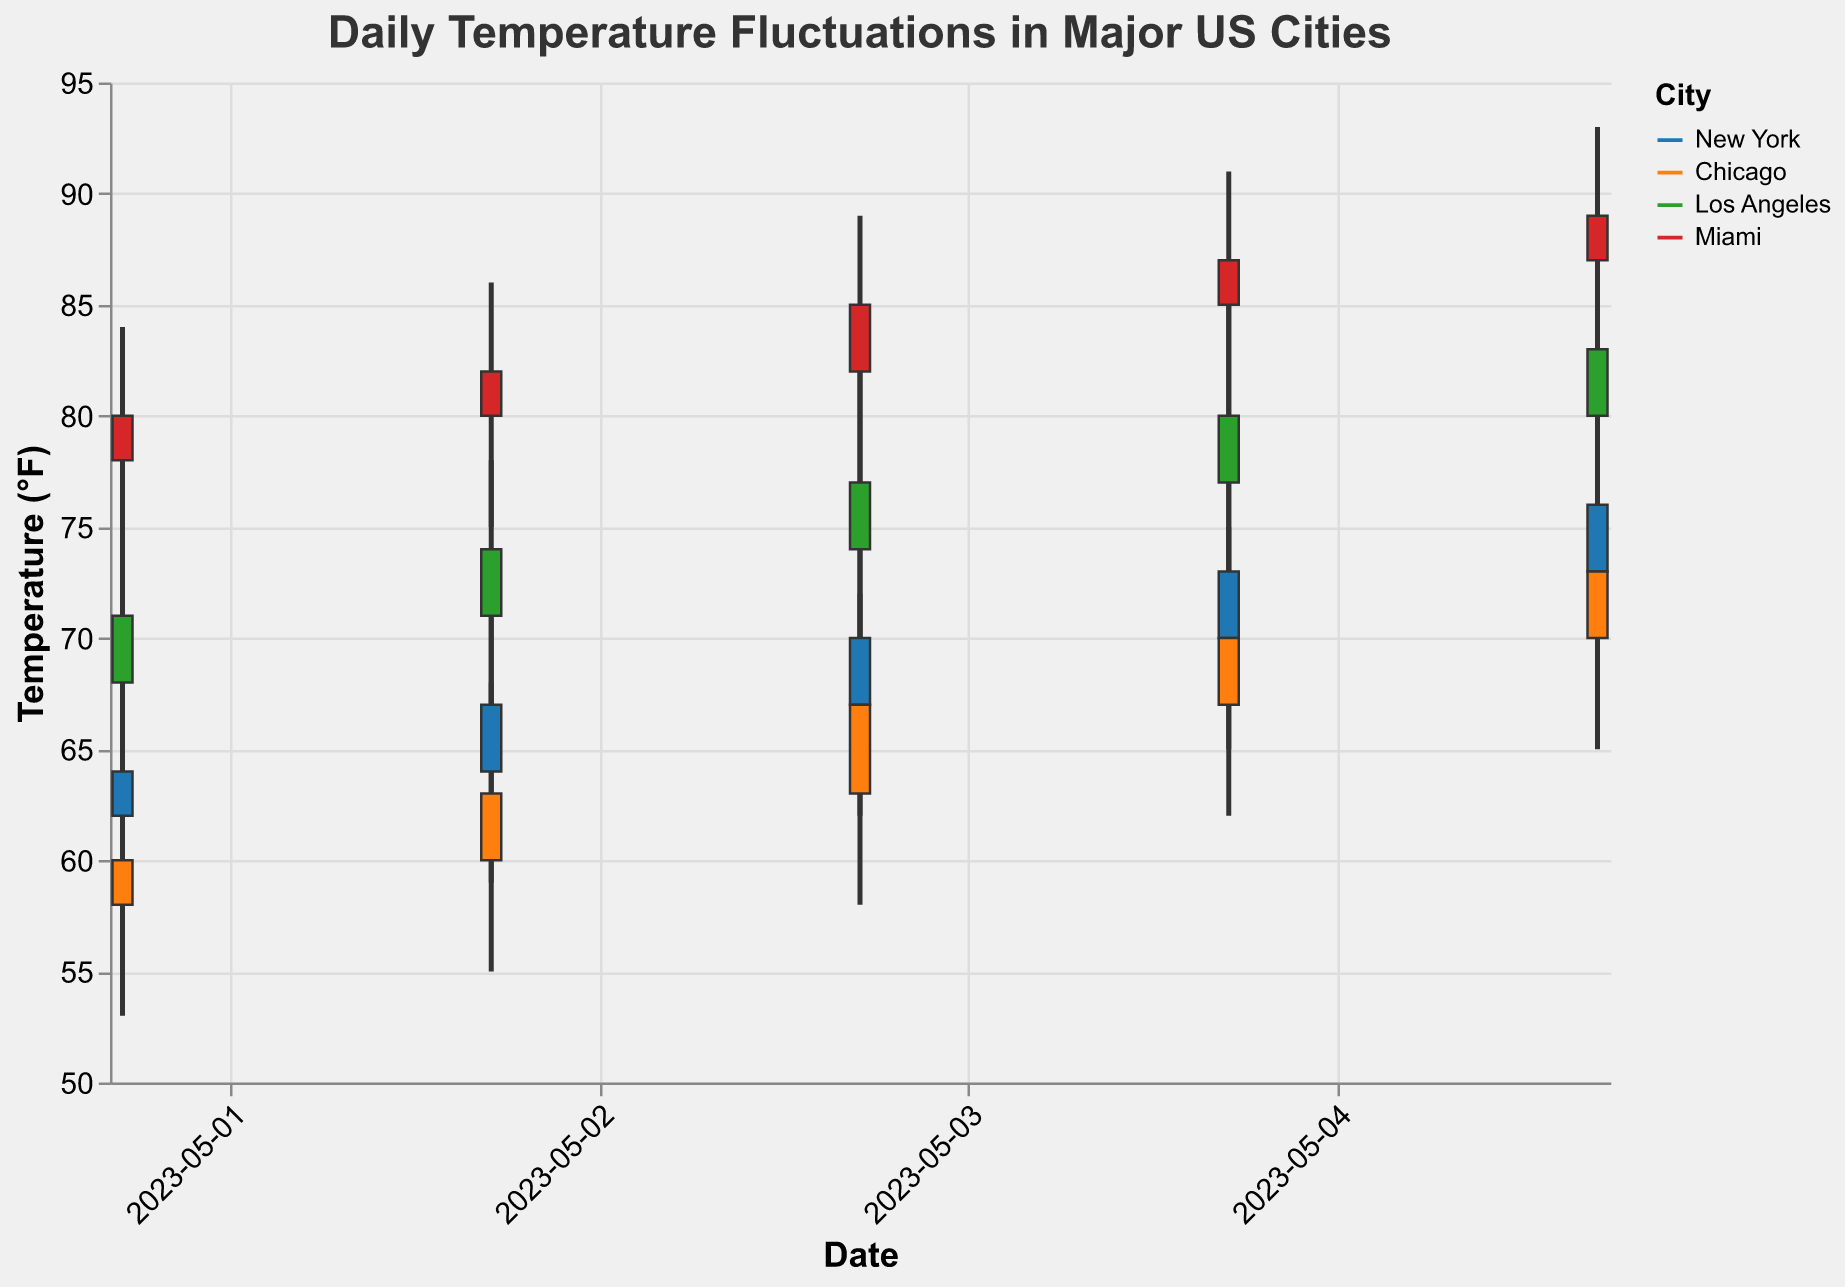What is the highest temperature recorded in New York during the 5 days shown? The highest temperature can be found by examining the "High" values for New York. The values are 68, 71, 75, 78, and 80. Among these, the highest is 80.
Answer: 80°F What city experienced the highest overall temperature? To determine which city experienced the highest temperature, we look at the "High" values for each city across all dates. The maximum values are: New York (80), Chicago (78), Los Angeles (88), and Miami (93). The highest among these is 93 in Miami.
Answer: Miami Which city had the smallest temperature range on May 03, 2023? To determine the smallest temperature range, we check the difference between the "High" and "Low" for each city on May 03. Calculations: New York (75 - 62 = 13), Chicago (72 - 58 = 14), Los Angeles (82 - 69 = 13), Miami (89 - 77 = 12). So, Miami has the smallest range.
Answer: Miami How did the closing temperature of New York change from May 01 to May 05? To observe the change, compare the "Close" values for New York on May 01 and May 05. On May 01, the closing temperature was 64°F, and on May 05, it was 76°F. The change is 76 - 64 = 12°F.
Answer: 12°F increase Which city had the most consistent temperatures over the 5 days? Consistency can be assessed by examining the day-to-day variation in closing temperatures. Checking the "Close" values: 
- New York: 64, 67, 70, 73, 76 (variations are 3, 3, 3, 3)
- Chicago: 60, 63, 67, 70, 73 (variations are 3, 4, 3, 3)
- Los Angeles: 71, 74, 77, 80, 83 (variations are 3, 3, 3, 3)
- Miami: 80, 82, 85, 87, 89 (variations are 2, 3, 2, 2)
Miami has the smallest daily variations overall.
Answer: Miami On which date did Chicago have its highest daily temperature? To find the date with the highest temperature in Chicago, we examine the "High" values for Chicago. The highest is 78 on May 05.
Answer: May 05 Compare the temperature ranges (High - Low) for New York and Chicago on May 04. Which city had a larger range? Calculate the temperature ranges for both cities on May 04:
- New York: 78 - 65 = 13
- Chicago: 75 - 62 = 13
The ranges are the same for both cities.
Answer: Both had the same range Which city had the highest average closing temperature over the 5 days? Calculate the average closing temperature for each city by summing their respective "Close" values and dividing by 5:
- New York: (64 + 67 + 70 + 73 + 76) / 5 = 70
- Chicago: (60 + 63 + 67 + 70 + 73) / 5 = 66.6
- Los Angeles: (71 + 74 + 77 + 80 + 83) / 5 = 77
- Miami: (80 + 82 + 85 + 87 + 89) / 5 = 84.6
Miami had the highest average.
Answer: Miami 